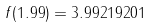<formula> <loc_0><loc_0><loc_500><loc_500>f ( 1 . 9 9 ) = 3 . 9 9 2 1 9 2 0 1</formula> 